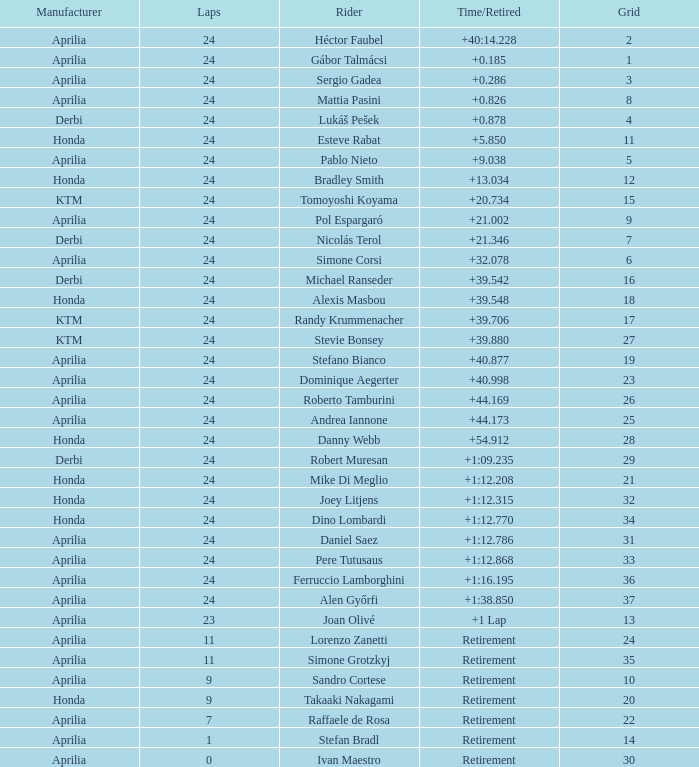How many grids correspond to more than 24 laps? None. 